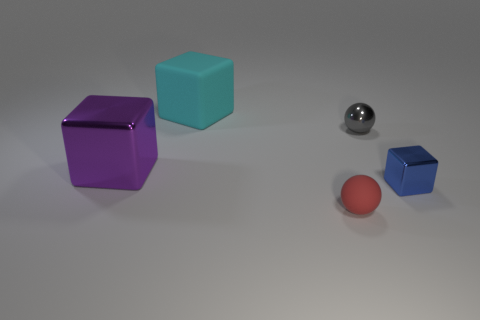Subtract all cyan rubber blocks. How many blocks are left? 2 Subtract all purple blocks. How many blocks are left? 2 Subtract all cubes. How many objects are left? 2 Subtract 1 blocks. How many blocks are left? 2 Add 1 cubes. How many objects exist? 6 Subtract all brown balls. Subtract all blue cylinders. How many balls are left? 2 Subtract all green cylinders. How many blue balls are left? 0 Subtract all gray balls. Subtract all tiny green spheres. How many objects are left? 4 Add 2 small things. How many small things are left? 5 Add 2 small matte spheres. How many small matte spheres exist? 3 